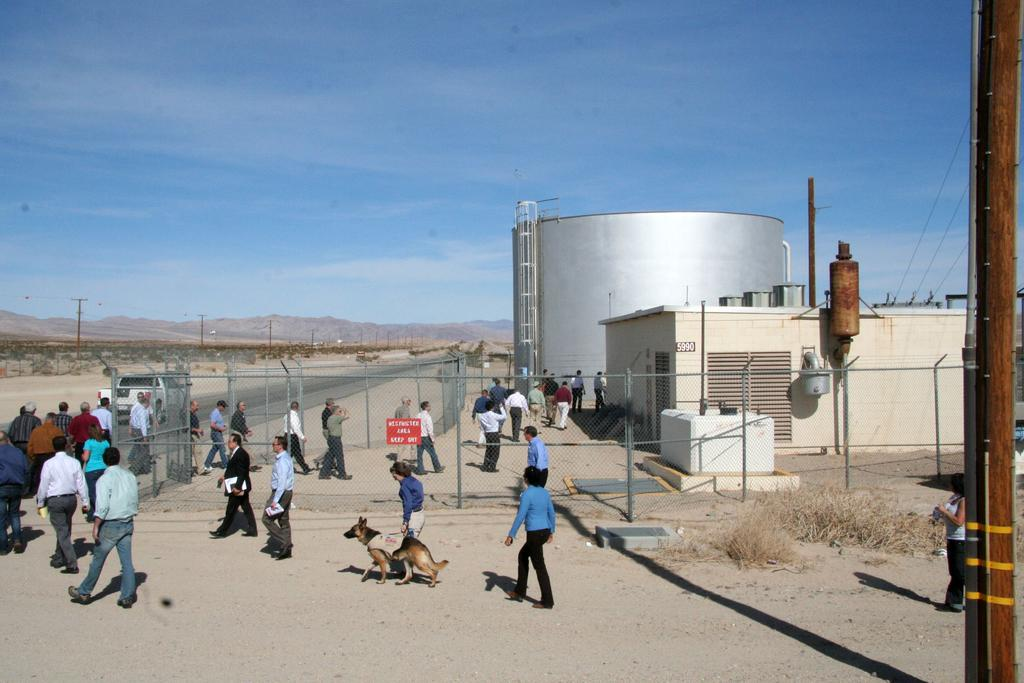How many people are in the image? There are people in the image, but the exact number is not specified. What can be seen in the background of the image? There is a fence, houses, current poles, and the sky visible in the image. What type of animal is present in the image? There is a dog in the image. What is the primary function of the current poles? The current poles are likely used for transmitting electricity. What type of lamp is hanging from the curtain in the image? There is no lamp or curtain present in the image. 